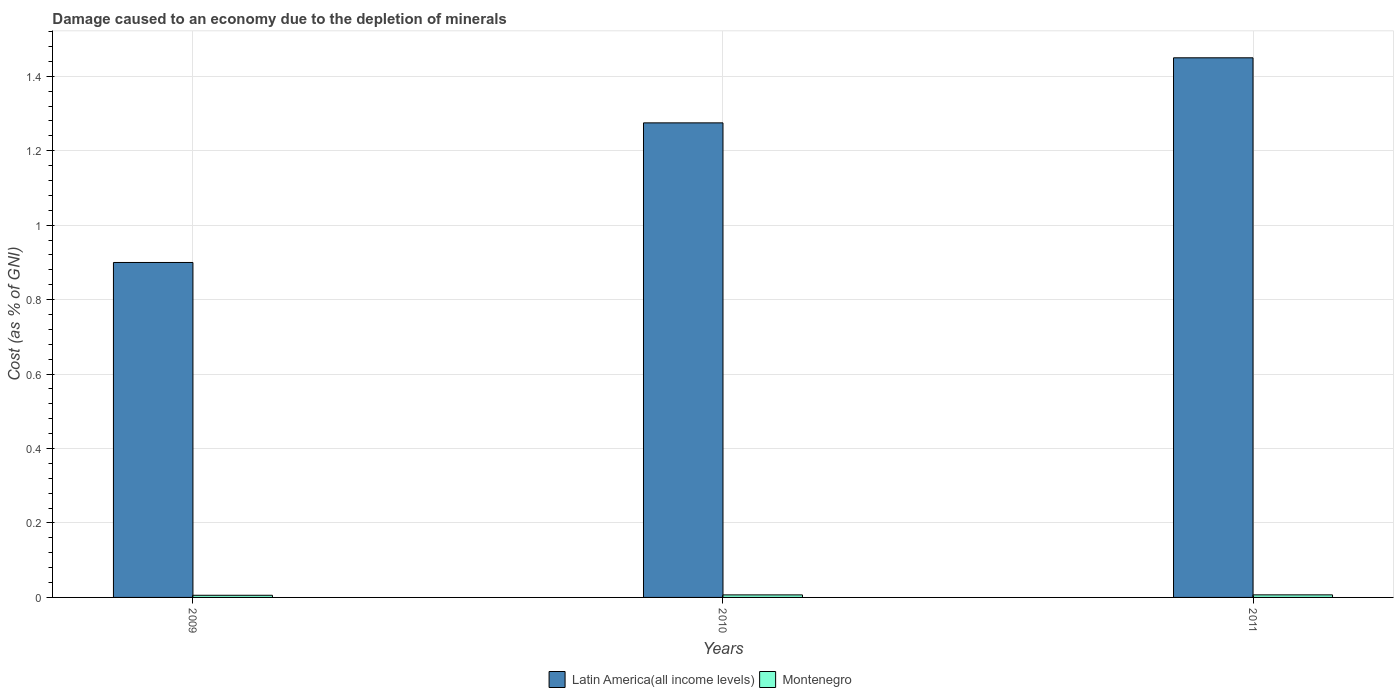How many different coloured bars are there?
Make the answer very short. 2. How many groups of bars are there?
Provide a succinct answer. 3. Are the number of bars per tick equal to the number of legend labels?
Provide a short and direct response. Yes. Are the number of bars on each tick of the X-axis equal?
Ensure brevity in your answer.  Yes. How many bars are there on the 1st tick from the left?
Ensure brevity in your answer.  2. What is the label of the 1st group of bars from the left?
Your response must be concise. 2009. What is the cost of damage caused due to the depletion of minerals in Montenegro in 2009?
Your answer should be compact. 0.01. Across all years, what is the maximum cost of damage caused due to the depletion of minerals in Montenegro?
Ensure brevity in your answer.  0.01. Across all years, what is the minimum cost of damage caused due to the depletion of minerals in Latin America(all income levels)?
Offer a very short reply. 0.9. In which year was the cost of damage caused due to the depletion of minerals in Montenegro minimum?
Ensure brevity in your answer.  2009. What is the total cost of damage caused due to the depletion of minerals in Latin America(all income levels) in the graph?
Make the answer very short. 3.62. What is the difference between the cost of damage caused due to the depletion of minerals in Montenegro in 2009 and that in 2010?
Your response must be concise. -0. What is the difference between the cost of damage caused due to the depletion of minerals in Latin America(all income levels) in 2011 and the cost of damage caused due to the depletion of minerals in Montenegro in 2010?
Your answer should be compact. 1.44. What is the average cost of damage caused due to the depletion of minerals in Latin America(all income levels) per year?
Make the answer very short. 1.21. In the year 2010, what is the difference between the cost of damage caused due to the depletion of minerals in Latin America(all income levels) and cost of damage caused due to the depletion of minerals in Montenegro?
Your answer should be compact. 1.27. What is the ratio of the cost of damage caused due to the depletion of minerals in Latin America(all income levels) in 2009 to that in 2011?
Your response must be concise. 0.62. Is the cost of damage caused due to the depletion of minerals in Montenegro in 2009 less than that in 2011?
Provide a short and direct response. Yes. What is the difference between the highest and the second highest cost of damage caused due to the depletion of minerals in Montenegro?
Your answer should be very brief. 8.786243723871937e-5. What is the difference between the highest and the lowest cost of damage caused due to the depletion of minerals in Montenegro?
Your answer should be compact. 0. What does the 2nd bar from the left in 2011 represents?
Your response must be concise. Montenegro. What does the 2nd bar from the right in 2010 represents?
Keep it short and to the point. Latin America(all income levels). How many years are there in the graph?
Provide a succinct answer. 3. Are the values on the major ticks of Y-axis written in scientific E-notation?
Offer a terse response. No. Does the graph contain any zero values?
Provide a short and direct response. No. Does the graph contain grids?
Provide a succinct answer. Yes. How are the legend labels stacked?
Offer a terse response. Horizontal. What is the title of the graph?
Offer a terse response. Damage caused to an economy due to the depletion of minerals. What is the label or title of the Y-axis?
Make the answer very short. Cost (as % of GNI). What is the Cost (as % of GNI) of Latin America(all income levels) in 2009?
Your answer should be very brief. 0.9. What is the Cost (as % of GNI) in Montenegro in 2009?
Keep it short and to the point. 0.01. What is the Cost (as % of GNI) of Latin America(all income levels) in 2010?
Offer a terse response. 1.27. What is the Cost (as % of GNI) in Montenegro in 2010?
Your answer should be compact. 0.01. What is the Cost (as % of GNI) in Latin America(all income levels) in 2011?
Give a very brief answer. 1.45. What is the Cost (as % of GNI) in Montenegro in 2011?
Keep it short and to the point. 0.01. Across all years, what is the maximum Cost (as % of GNI) in Latin America(all income levels)?
Your answer should be very brief. 1.45. Across all years, what is the maximum Cost (as % of GNI) of Montenegro?
Make the answer very short. 0.01. Across all years, what is the minimum Cost (as % of GNI) of Latin America(all income levels)?
Make the answer very short. 0.9. Across all years, what is the minimum Cost (as % of GNI) in Montenegro?
Your response must be concise. 0.01. What is the total Cost (as % of GNI) of Latin America(all income levels) in the graph?
Ensure brevity in your answer.  3.62. What is the total Cost (as % of GNI) of Montenegro in the graph?
Your answer should be compact. 0.02. What is the difference between the Cost (as % of GNI) of Latin America(all income levels) in 2009 and that in 2010?
Your answer should be compact. -0.38. What is the difference between the Cost (as % of GNI) in Montenegro in 2009 and that in 2010?
Keep it short and to the point. -0. What is the difference between the Cost (as % of GNI) of Latin America(all income levels) in 2009 and that in 2011?
Your answer should be compact. -0.55. What is the difference between the Cost (as % of GNI) of Montenegro in 2009 and that in 2011?
Provide a succinct answer. -0. What is the difference between the Cost (as % of GNI) of Latin America(all income levels) in 2010 and that in 2011?
Provide a succinct answer. -0.17. What is the difference between the Cost (as % of GNI) of Montenegro in 2010 and that in 2011?
Give a very brief answer. -0. What is the difference between the Cost (as % of GNI) in Latin America(all income levels) in 2009 and the Cost (as % of GNI) in Montenegro in 2010?
Your answer should be compact. 0.89. What is the difference between the Cost (as % of GNI) in Latin America(all income levels) in 2009 and the Cost (as % of GNI) in Montenegro in 2011?
Provide a short and direct response. 0.89. What is the difference between the Cost (as % of GNI) of Latin America(all income levels) in 2010 and the Cost (as % of GNI) of Montenegro in 2011?
Your answer should be compact. 1.27. What is the average Cost (as % of GNI) in Latin America(all income levels) per year?
Ensure brevity in your answer.  1.21. What is the average Cost (as % of GNI) of Montenegro per year?
Your response must be concise. 0.01. In the year 2009, what is the difference between the Cost (as % of GNI) in Latin America(all income levels) and Cost (as % of GNI) in Montenegro?
Offer a very short reply. 0.89. In the year 2010, what is the difference between the Cost (as % of GNI) in Latin America(all income levels) and Cost (as % of GNI) in Montenegro?
Offer a very short reply. 1.27. In the year 2011, what is the difference between the Cost (as % of GNI) in Latin America(all income levels) and Cost (as % of GNI) in Montenegro?
Keep it short and to the point. 1.44. What is the ratio of the Cost (as % of GNI) in Latin America(all income levels) in 2009 to that in 2010?
Your response must be concise. 0.71. What is the ratio of the Cost (as % of GNI) in Montenegro in 2009 to that in 2010?
Offer a terse response. 0.85. What is the ratio of the Cost (as % of GNI) in Latin America(all income levels) in 2009 to that in 2011?
Make the answer very short. 0.62. What is the ratio of the Cost (as % of GNI) of Montenegro in 2009 to that in 2011?
Your response must be concise. 0.84. What is the ratio of the Cost (as % of GNI) in Latin America(all income levels) in 2010 to that in 2011?
Keep it short and to the point. 0.88. What is the ratio of the Cost (as % of GNI) in Montenegro in 2010 to that in 2011?
Make the answer very short. 0.99. What is the difference between the highest and the second highest Cost (as % of GNI) in Latin America(all income levels)?
Your answer should be compact. 0.17. What is the difference between the highest and the lowest Cost (as % of GNI) of Latin America(all income levels)?
Keep it short and to the point. 0.55. What is the difference between the highest and the lowest Cost (as % of GNI) in Montenegro?
Your answer should be very brief. 0. 